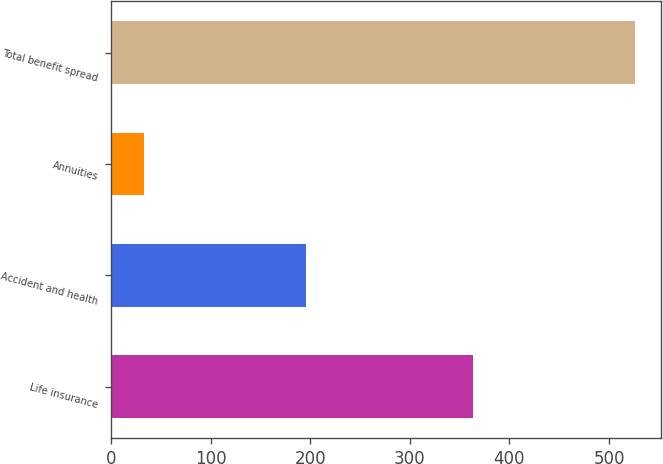Convert chart. <chart><loc_0><loc_0><loc_500><loc_500><bar_chart><fcel>Life insurance<fcel>Accident and health<fcel>Annuities<fcel>Total benefit spread<nl><fcel>363<fcel>196<fcel>33<fcel>526<nl></chart> 